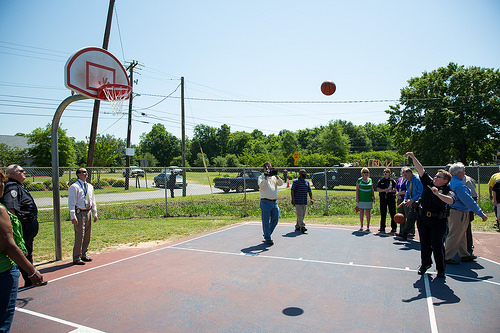<image>
Can you confirm if the ground is under the ball? Yes. The ground is positioned underneath the ball, with the ball above it in the vertical space. Is the ball behind the basket? No. The ball is not behind the basket. From this viewpoint, the ball appears to be positioned elsewhere in the scene. 